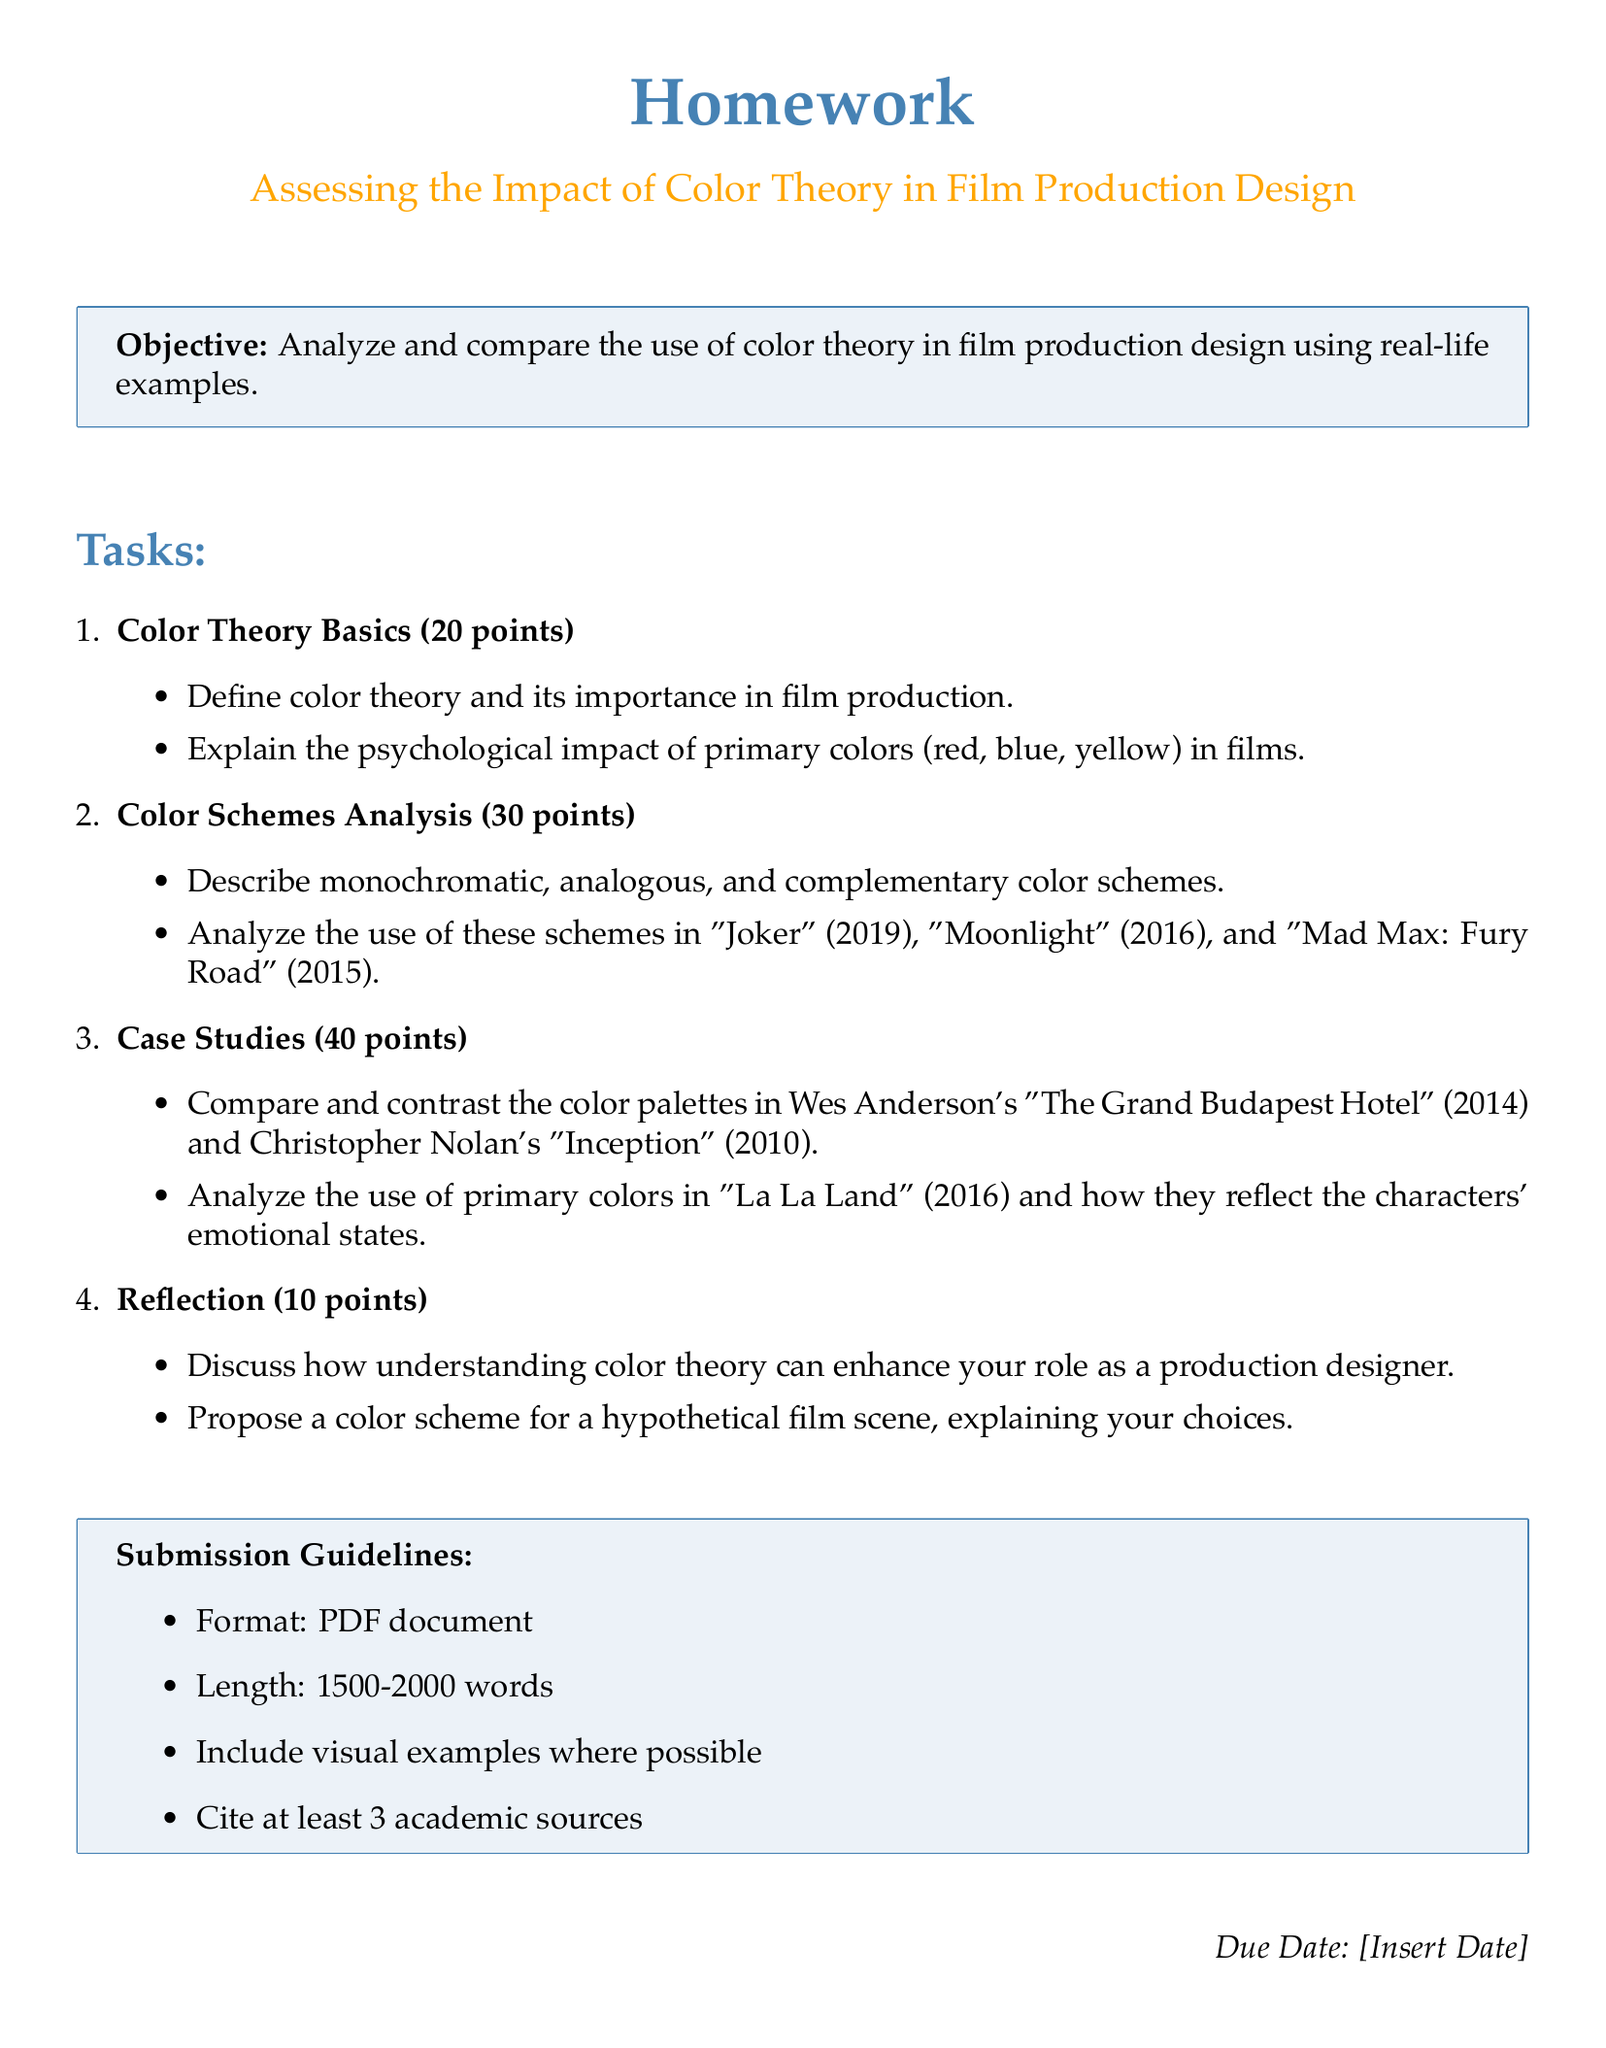What is the title of the homework? The title is the heading of the homework document, which summarizes its content.
Answer: Assessing the Impact of Color Theory in Film Production Design How many points are allocated for Color Theory Basics? The points are listed next to each task in the document.
Answer: 20 points Which film is analyzed for its color schemes in the homework? The films are listed under the Color Schemes Analysis section.
Answer: Joker, Moonlight, Mad Max: Fury Road What is the total number of tasks in the document? The tasks are counted in the enumerated list in the document.
Answer: 4 What is the length requirement for the submission? The length requirement is specified in the submission guidelines.
Answer: 1500-2000 words Who directed "The Grand Budapest Hotel"? The director of the film is indicated within the case studies section.
Answer: Wes Anderson What color schemes are to be described in the analysis? The color schemes to be described are outlined in the document.
Answer: Monochromatic, analogous, complementary What is required to support the analysis in the homework? The requirements are mentioned in the submission guidelines section.
Answer: Visual examples What is the due date for the homework? The due date is implied as a placeholder in the document format.
Answer: [Insert Date] 